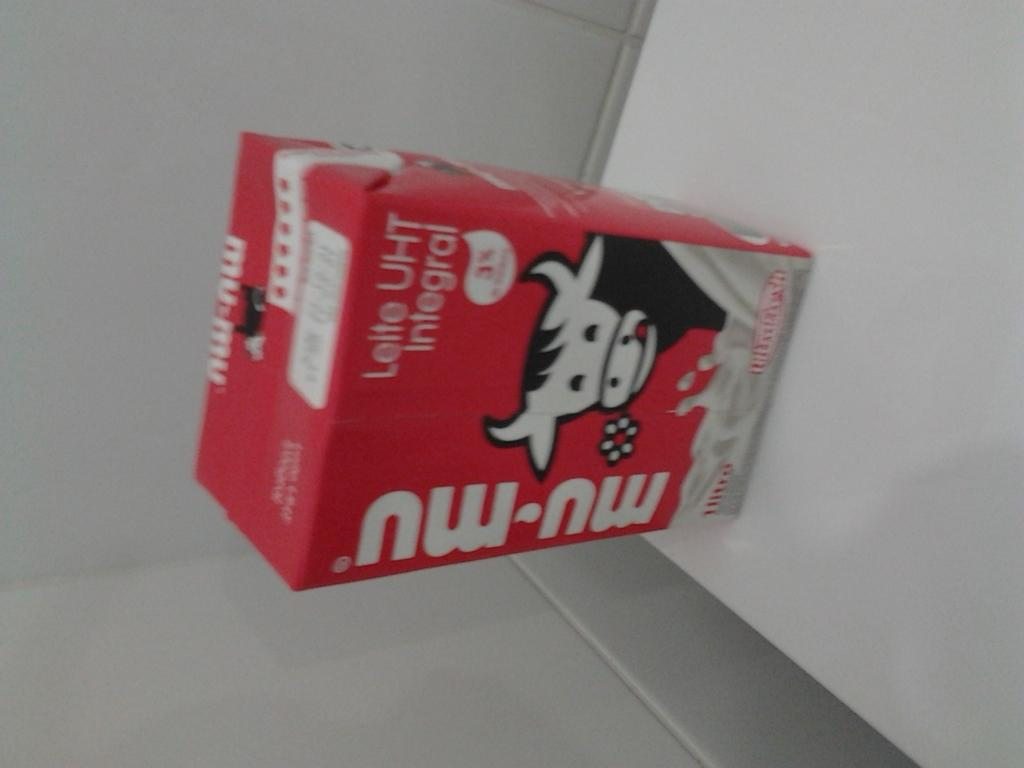What is the main object in the image? There is a milk tetra pack in the image. Where is the milk tetra pack located? The milk tetra pack is kept on a table. What can be seen on the wall in the image? There are white tiles on the wall in the image. How many basketballs can be seen on the table with the milk tetra pack? There are no basketballs present in the image; it only features a milk tetra pack on a table and white tiles on the wall. 